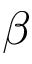Convert formula to latex. <formula><loc_0><loc_0><loc_500><loc_500>\beta</formula> 